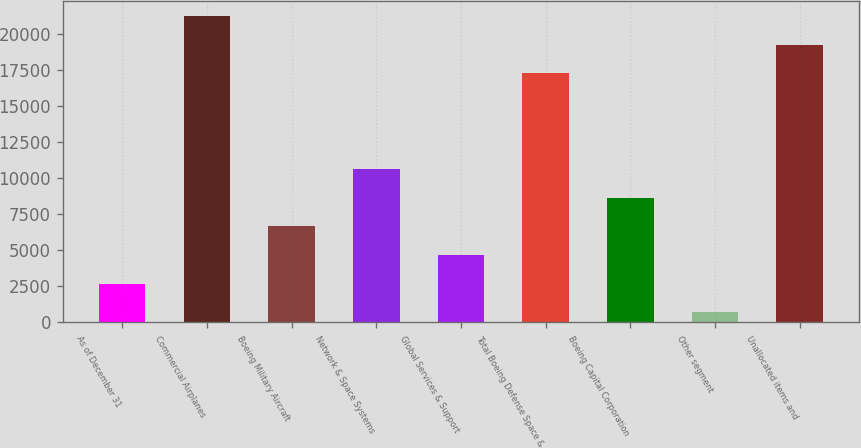Convert chart. <chart><loc_0><loc_0><loc_500><loc_500><bar_chart><fcel>As of December 31<fcel>Commercial Airplanes<fcel>Boeing Military Aircraft<fcel>Network & Space Systems<fcel>Global Services & Support<fcel>Total Boeing Defense Space &<fcel>Boeing Capital Corporation<fcel>Other segment<fcel>Unallocated items and<nl><fcel>2691.1<fcel>21240.2<fcel>6659.3<fcel>10627.5<fcel>4675.2<fcel>17272<fcel>8643.4<fcel>707<fcel>19256.1<nl></chart> 